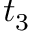Convert formula to latex. <formula><loc_0><loc_0><loc_500><loc_500>t _ { 3 }</formula> 